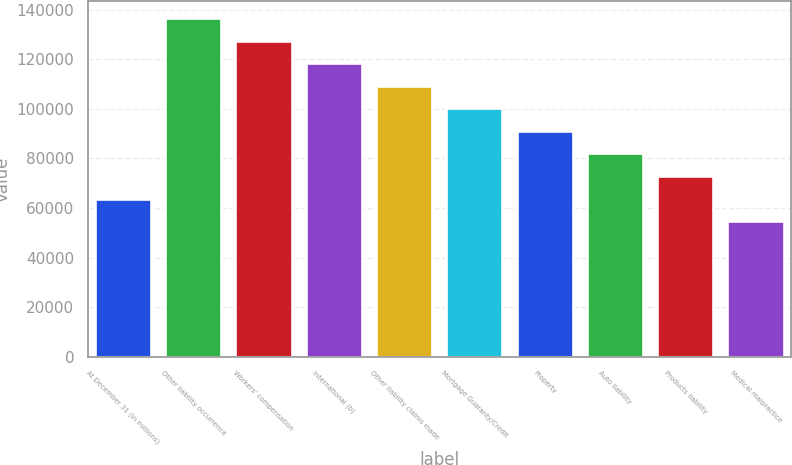<chart> <loc_0><loc_0><loc_500><loc_500><bar_chart><fcel>At December 31 (in millions)<fcel>Other liability occurrence<fcel>Workers' compensation<fcel>International (b)<fcel>Other liability claims made<fcel>Mortgage Guaranty/Credit<fcel>Property<fcel>Auto liability<fcel>Products liability<fcel>Medical malpractice<nl><fcel>63844.7<fcel>136662<fcel>127559<fcel>118457<fcel>109355<fcel>100253<fcel>91151<fcel>82048.9<fcel>72946.8<fcel>54742.6<nl></chart> 